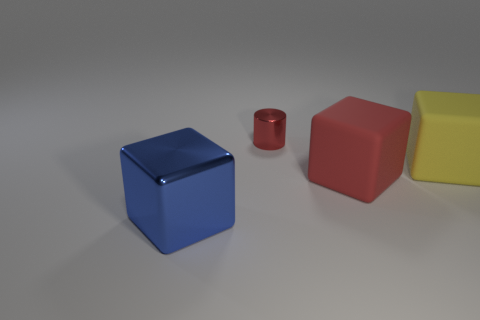What shape is the red thing on the right side of the metal object that is behind the matte thing in front of the big yellow matte cube?
Your answer should be compact. Cube. There is a big cube that is on the left side of the big red matte thing that is on the right side of the small metal thing; what is it made of?
Your response must be concise. Metal. There is a tiny thing that is the same material as the big blue cube; what is its shape?
Give a very brief answer. Cylinder. Is there any other thing that has the same shape as the big yellow object?
Make the answer very short. Yes. There is a small red cylinder; how many tiny red cylinders are behind it?
Provide a short and direct response. 0. Are there any metal balls?
Your answer should be compact. No. What color is the metallic object that is left of the red shiny cylinder that is behind the red object that is in front of the small thing?
Your response must be concise. Blue. Are there any large red matte things that are in front of the metal object in front of the red cylinder?
Offer a very short reply. No. Do the metal object that is behind the blue thing and the big cube to the left of the red shiny cylinder have the same color?
Give a very brief answer. No. How many yellow matte things are the same size as the red rubber object?
Give a very brief answer. 1. 